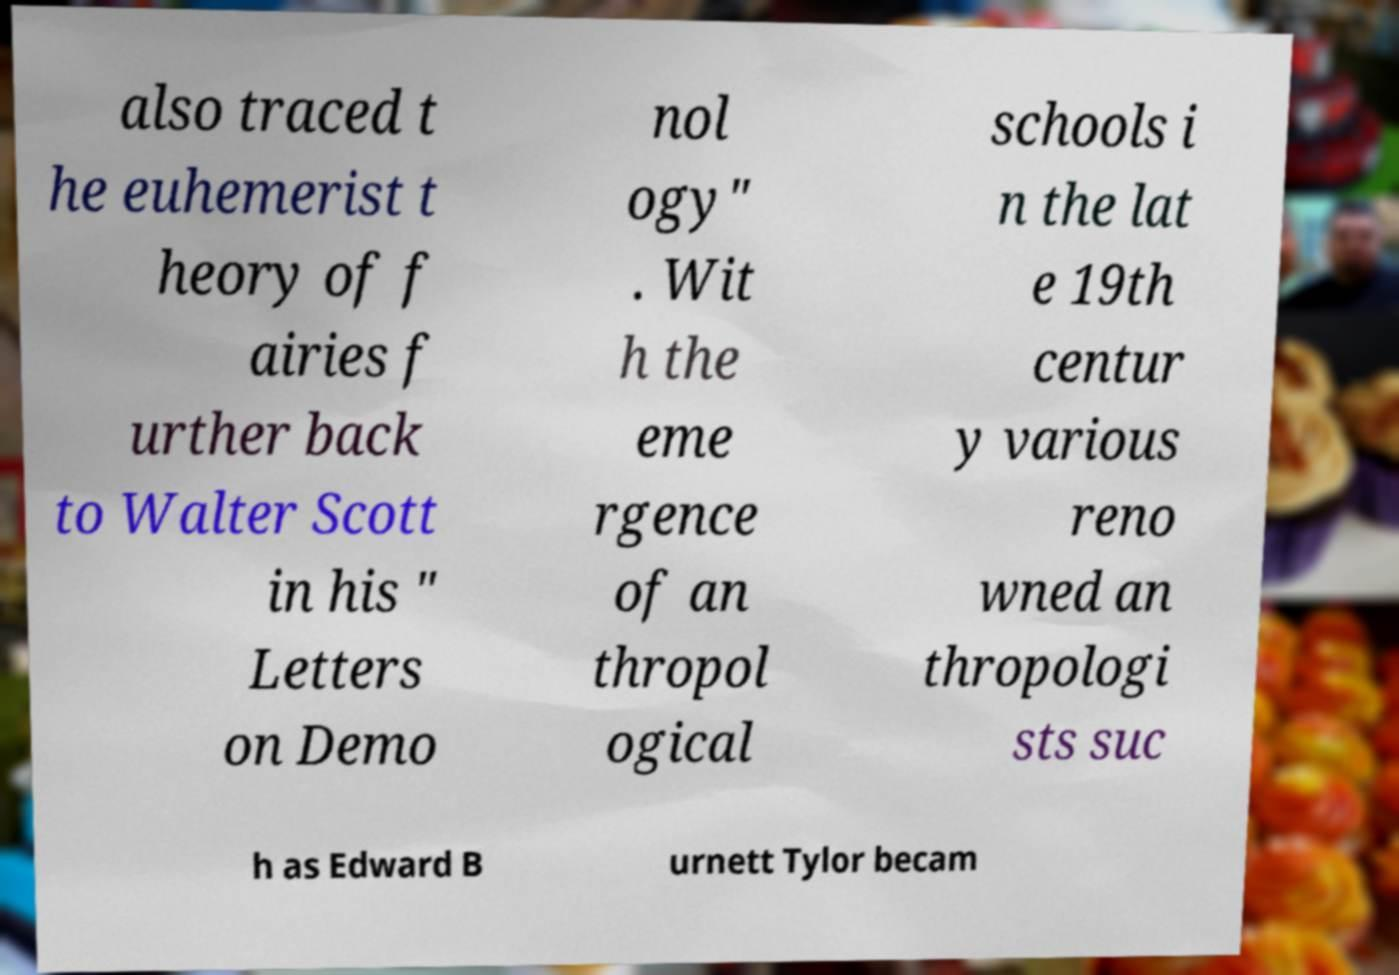For documentation purposes, I need the text within this image transcribed. Could you provide that? also traced t he euhemerist t heory of f airies f urther back to Walter Scott in his " Letters on Demo nol ogy" . Wit h the eme rgence of an thropol ogical schools i n the lat e 19th centur y various reno wned an thropologi sts suc h as Edward B urnett Tylor becam 